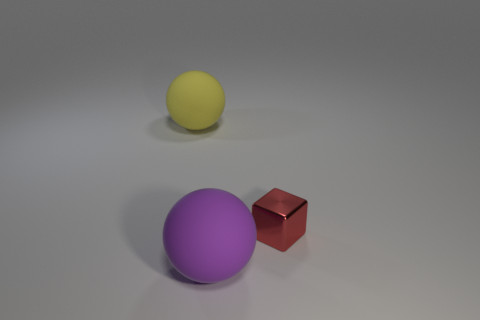Is there any other thing that is the same shape as the red thing?
Offer a terse response. No. There is a thing that is both left of the red block and right of the large yellow sphere; what is its material?
Keep it short and to the point. Rubber. Is the number of tiny cubes greater than the number of small purple cubes?
Offer a terse response. Yes. What is the color of the cube that is right of the matte ball in front of the sphere behind the tiny metal object?
Make the answer very short. Red. Do the sphere in front of the tiny red shiny object and the cube have the same material?
Provide a succinct answer. No. Is there a brown matte cube?
Make the answer very short. No. Does the sphere in front of the yellow object have the same size as the metal object?
Make the answer very short. No. Are there fewer large purple rubber balls than tiny brown cylinders?
Offer a very short reply. No. There is a tiny red thing in front of the big matte thing that is to the left of the large sphere that is in front of the red object; what shape is it?
Keep it short and to the point. Cube. Are there any tiny purple things that have the same material as the large purple thing?
Provide a short and direct response. No. 